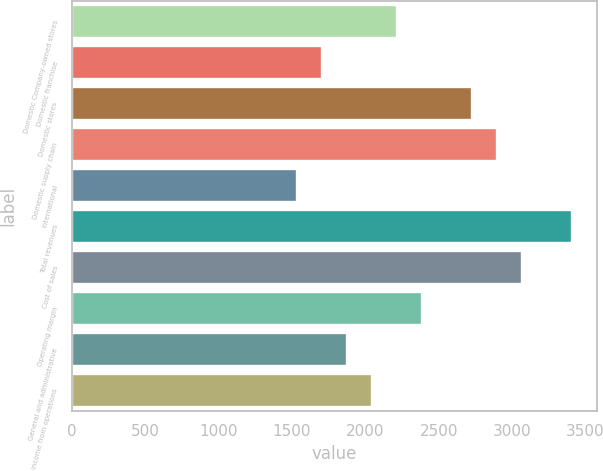<chart> <loc_0><loc_0><loc_500><loc_500><bar_chart><fcel>Domestic Company-owned stores<fcel>Domestic franchise<fcel>Domestic stores<fcel>Domestic supply chain<fcel>International<fcel>Total revenues<fcel>Cost of sales<fcel>Operating margin<fcel>General and administrative<fcel>Income from operations<nl><fcel>2216<fcel>1704.83<fcel>2727.17<fcel>2897.56<fcel>1534.44<fcel>3408.73<fcel>3067.95<fcel>2386.39<fcel>1875.22<fcel>2045.61<nl></chart> 